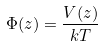Convert formula to latex. <formula><loc_0><loc_0><loc_500><loc_500>\Phi ( z ) = \frac { V ( z ) } { k T }</formula> 